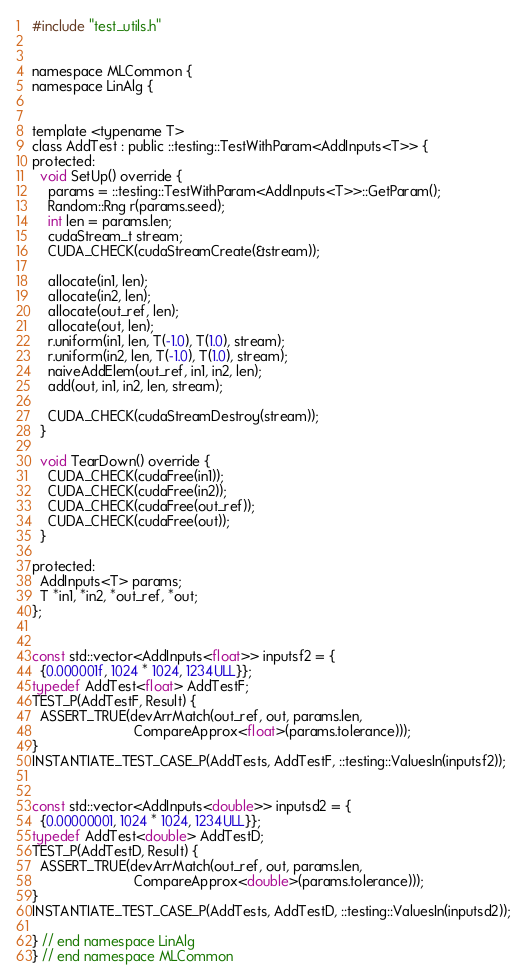Convert code to text. <code><loc_0><loc_0><loc_500><loc_500><_Cuda_>#include "test_utils.h"


namespace MLCommon {
namespace LinAlg {


template <typename T>
class AddTest : public ::testing::TestWithParam<AddInputs<T>> {
protected:
  void SetUp() override {
    params = ::testing::TestWithParam<AddInputs<T>>::GetParam();
    Random::Rng r(params.seed);
    int len = params.len;
    cudaStream_t stream;
    CUDA_CHECK(cudaStreamCreate(&stream));

    allocate(in1, len);
    allocate(in2, len);
    allocate(out_ref, len);
    allocate(out, len);
    r.uniform(in1, len, T(-1.0), T(1.0), stream);
    r.uniform(in2, len, T(-1.0), T(1.0), stream);
    naiveAddElem(out_ref, in1, in2, len);
    add(out, in1, in2, len, stream);

    CUDA_CHECK(cudaStreamDestroy(stream));
  }

  void TearDown() override {
    CUDA_CHECK(cudaFree(in1));
    CUDA_CHECK(cudaFree(in2));
    CUDA_CHECK(cudaFree(out_ref));
    CUDA_CHECK(cudaFree(out));
  }

protected:
  AddInputs<T> params;
  T *in1, *in2, *out_ref, *out;
};


const std::vector<AddInputs<float>> inputsf2 = {
  {0.000001f, 1024 * 1024, 1234ULL}};
typedef AddTest<float> AddTestF;
TEST_P(AddTestF, Result) {
  ASSERT_TRUE(devArrMatch(out_ref, out, params.len,
                          CompareApprox<float>(params.tolerance)));
}
INSTANTIATE_TEST_CASE_P(AddTests, AddTestF, ::testing::ValuesIn(inputsf2));


const std::vector<AddInputs<double>> inputsd2 = {
  {0.00000001, 1024 * 1024, 1234ULL}};
typedef AddTest<double> AddTestD;
TEST_P(AddTestD, Result) {
  ASSERT_TRUE(devArrMatch(out_ref, out, params.len,
                          CompareApprox<double>(params.tolerance)));
}
INSTANTIATE_TEST_CASE_P(AddTests, AddTestD, ::testing::ValuesIn(inputsd2));

} // end namespace LinAlg
} // end namespace MLCommon
</code> 